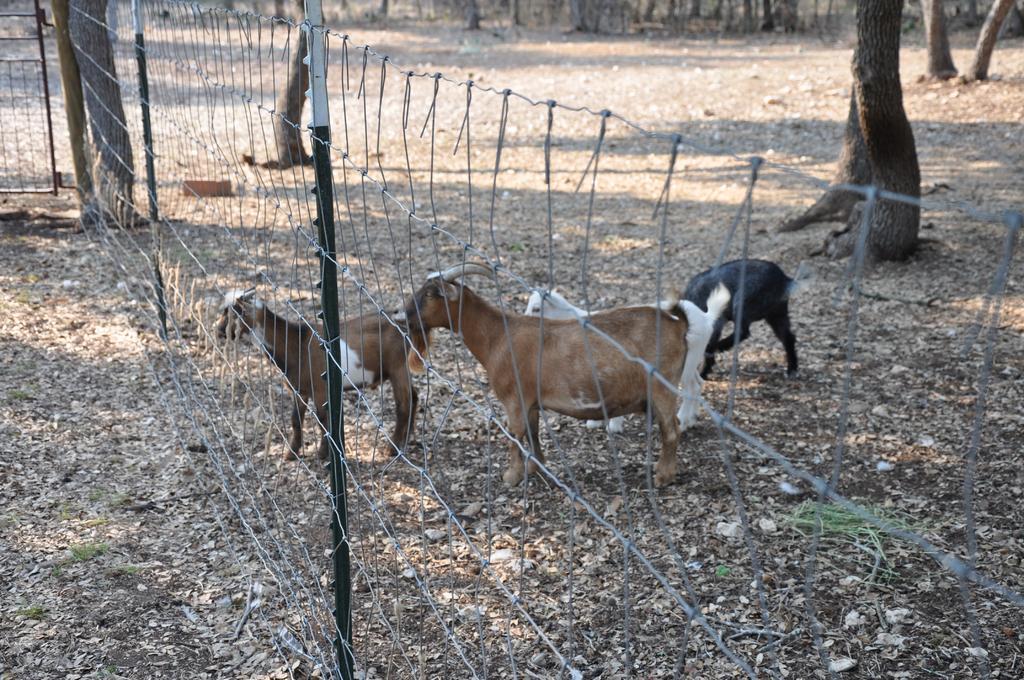In one or two sentences, can you explain what this image depicts? In this picture we can see few goats in front of the fence, and we can see few trees and metal rods. 